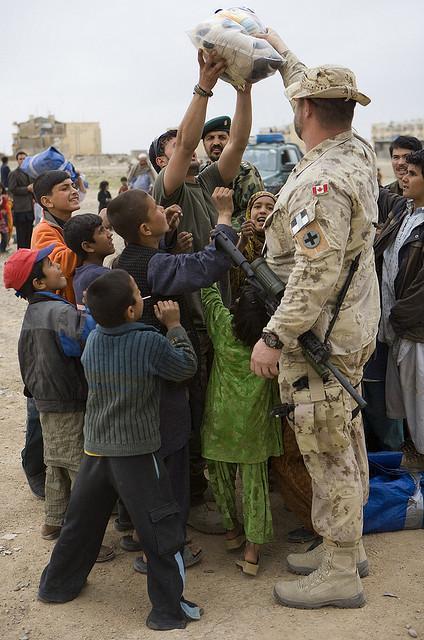How many people are visible?
Give a very brief answer. 11. 